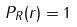<formula> <loc_0><loc_0><loc_500><loc_500>P _ { R } ( r ) = 1</formula> 